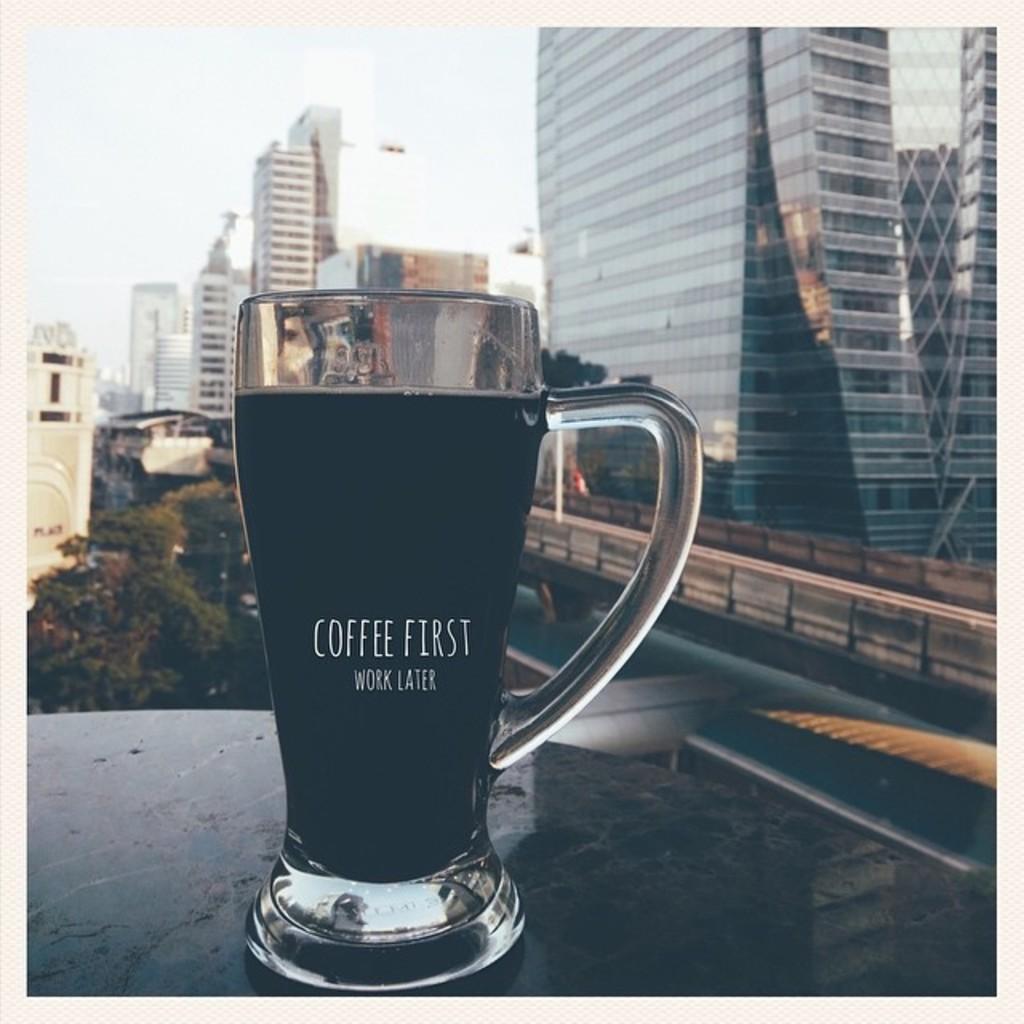What kind of drink is this?
Make the answer very short. Coffee. What is written on this glass?
Provide a short and direct response. Coffee first work later. 